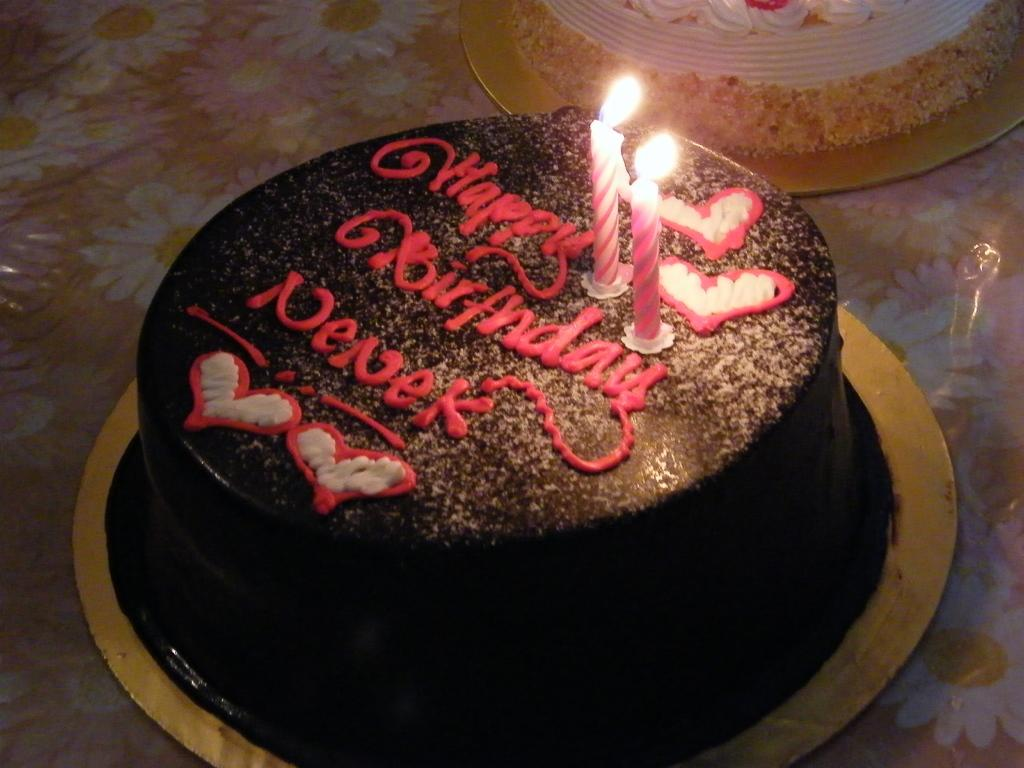What is the main subject of the image? There is a cake in the center of the image. Are there any decorations on the cake? Yes, the cake has candles on it. Is there more than one cake in the image? Yes, there is another cake on top of the first cake. What type of cord is used to tie the two cakes together in the image? There is no cord used to tie the two cakes together in the image; they are simply stacked on top of each other. 